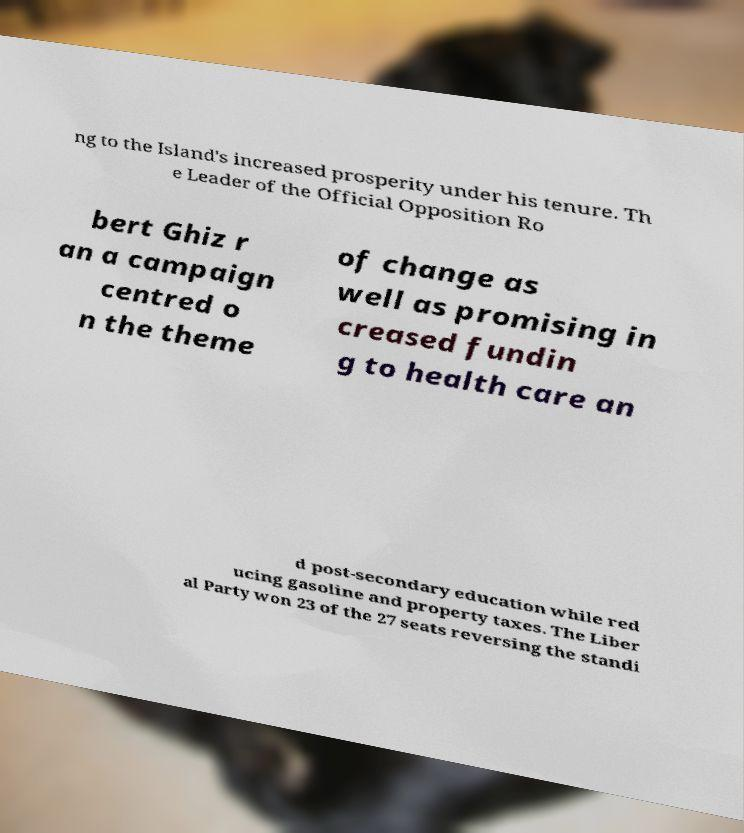Can you read and provide the text displayed in the image?This photo seems to have some interesting text. Can you extract and type it out for me? ng to the Island's increased prosperity under his tenure. Th e Leader of the Official Opposition Ro bert Ghiz r an a campaign centred o n the theme of change as well as promising in creased fundin g to health care an d post-secondary education while red ucing gasoline and property taxes. The Liber al Party won 23 of the 27 seats reversing the standi 